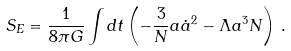Convert formula to latex. <formula><loc_0><loc_0><loc_500><loc_500>S _ { E } = \frac { 1 } { 8 \pi G } \int d t \left ( - \frac { 3 } { N } a \dot { a } ^ { 2 } - \Lambda a ^ { 3 } N \right ) \, .</formula> 